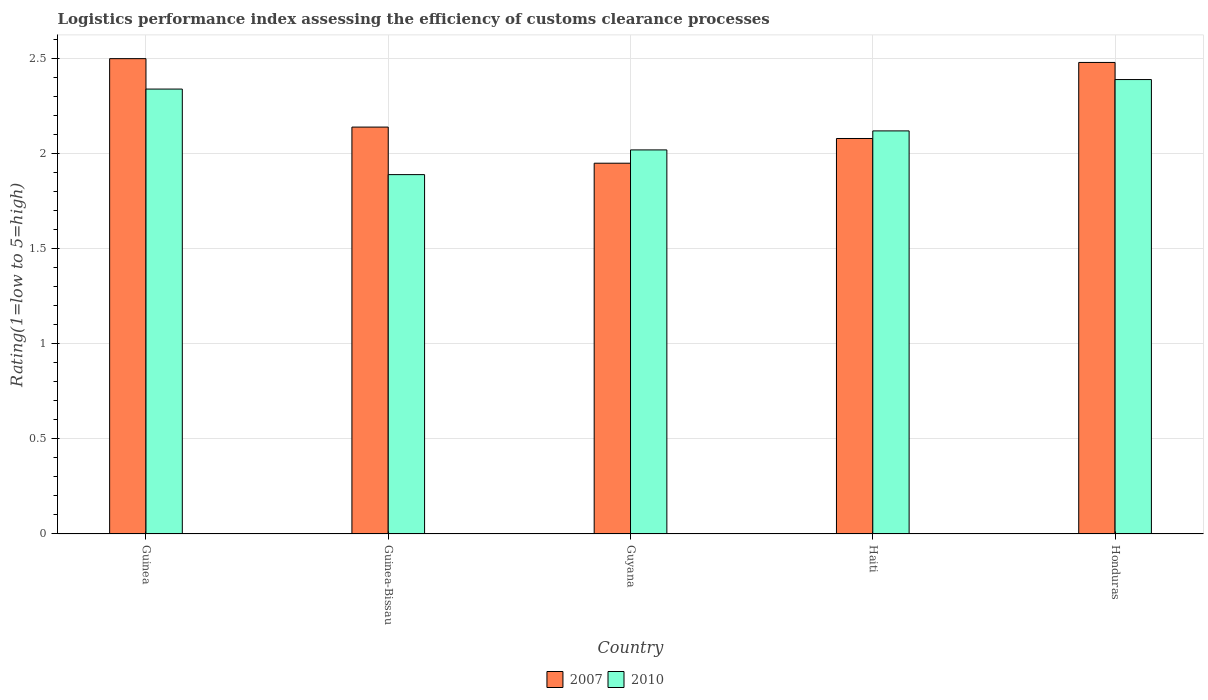How many different coloured bars are there?
Your response must be concise. 2. How many groups of bars are there?
Offer a terse response. 5. Are the number of bars per tick equal to the number of legend labels?
Give a very brief answer. Yes. Are the number of bars on each tick of the X-axis equal?
Offer a terse response. Yes. How many bars are there on the 2nd tick from the left?
Your response must be concise. 2. What is the label of the 3rd group of bars from the left?
Offer a very short reply. Guyana. In how many cases, is the number of bars for a given country not equal to the number of legend labels?
Provide a short and direct response. 0. What is the Logistic performance index in 2010 in Honduras?
Your answer should be very brief. 2.39. Across all countries, what is the maximum Logistic performance index in 2010?
Your answer should be compact. 2.39. Across all countries, what is the minimum Logistic performance index in 2007?
Give a very brief answer. 1.95. In which country was the Logistic performance index in 2007 maximum?
Make the answer very short. Guinea. In which country was the Logistic performance index in 2010 minimum?
Make the answer very short. Guinea-Bissau. What is the total Logistic performance index in 2007 in the graph?
Provide a succinct answer. 11.15. What is the difference between the Logistic performance index in 2007 in Guyana and that in Honduras?
Your answer should be compact. -0.53. What is the difference between the Logistic performance index in 2007 in Guinea-Bissau and the Logistic performance index in 2010 in Guyana?
Your response must be concise. 0.12. What is the average Logistic performance index in 2010 per country?
Your response must be concise. 2.15. What is the difference between the Logistic performance index of/in 2007 and Logistic performance index of/in 2010 in Haiti?
Offer a very short reply. -0.04. What is the ratio of the Logistic performance index in 2007 in Guinea to that in Honduras?
Your answer should be compact. 1.01. What is the difference between the highest and the second highest Logistic performance index in 2010?
Give a very brief answer. 0.05. What is the difference between the highest and the lowest Logistic performance index in 2007?
Provide a short and direct response. 0.55. Is the sum of the Logistic performance index in 2007 in Guinea and Guinea-Bissau greater than the maximum Logistic performance index in 2010 across all countries?
Offer a terse response. Yes. Where does the legend appear in the graph?
Your answer should be very brief. Bottom center. How many legend labels are there?
Provide a succinct answer. 2. How are the legend labels stacked?
Keep it short and to the point. Horizontal. What is the title of the graph?
Give a very brief answer. Logistics performance index assessing the efficiency of customs clearance processes. What is the label or title of the X-axis?
Provide a short and direct response. Country. What is the label or title of the Y-axis?
Your answer should be very brief. Rating(1=low to 5=high). What is the Rating(1=low to 5=high) of 2007 in Guinea?
Offer a terse response. 2.5. What is the Rating(1=low to 5=high) in 2010 in Guinea?
Offer a terse response. 2.34. What is the Rating(1=low to 5=high) in 2007 in Guinea-Bissau?
Make the answer very short. 2.14. What is the Rating(1=low to 5=high) of 2010 in Guinea-Bissau?
Provide a succinct answer. 1.89. What is the Rating(1=low to 5=high) of 2007 in Guyana?
Ensure brevity in your answer.  1.95. What is the Rating(1=low to 5=high) of 2010 in Guyana?
Provide a short and direct response. 2.02. What is the Rating(1=low to 5=high) in 2007 in Haiti?
Provide a short and direct response. 2.08. What is the Rating(1=low to 5=high) in 2010 in Haiti?
Make the answer very short. 2.12. What is the Rating(1=low to 5=high) in 2007 in Honduras?
Your answer should be compact. 2.48. What is the Rating(1=low to 5=high) of 2010 in Honduras?
Give a very brief answer. 2.39. Across all countries, what is the maximum Rating(1=low to 5=high) of 2007?
Your response must be concise. 2.5. Across all countries, what is the maximum Rating(1=low to 5=high) in 2010?
Make the answer very short. 2.39. Across all countries, what is the minimum Rating(1=low to 5=high) of 2007?
Provide a succinct answer. 1.95. Across all countries, what is the minimum Rating(1=low to 5=high) in 2010?
Provide a succinct answer. 1.89. What is the total Rating(1=low to 5=high) of 2007 in the graph?
Ensure brevity in your answer.  11.15. What is the total Rating(1=low to 5=high) of 2010 in the graph?
Make the answer very short. 10.76. What is the difference between the Rating(1=low to 5=high) of 2007 in Guinea and that in Guinea-Bissau?
Your answer should be compact. 0.36. What is the difference between the Rating(1=low to 5=high) in 2010 in Guinea and that in Guinea-Bissau?
Your answer should be very brief. 0.45. What is the difference between the Rating(1=low to 5=high) in 2007 in Guinea and that in Guyana?
Offer a very short reply. 0.55. What is the difference between the Rating(1=low to 5=high) in 2010 in Guinea and that in Guyana?
Your response must be concise. 0.32. What is the difference between the Rating(1=low to 5=high) in 2007 in Guinea and that in Haiti?
Provide a short and direct response. 0.42. What is the difference between the Rating(1=low to 5=high) in 2010 in Guinea and that in Haiti?
Make the answer very short. 0.22. What is the difference between the Rating(1=low to 5=high) in 2007 in Guinea-Bissau and that in Guyana?
Provide a succinct answer. 0.19. What is the difference between the Rating(1=low to 5=high) in 2010 in Guinea-Bissau and that in Guyana?
Offer a terse response. -0.13. What is the difference between the Rating(1=low to 5=high) of 2010 in Guinea-Bissau and that in Haiti?
Your response must be concise. -0.23. What is the difference between the Rating(1=low to 5=high) of 2007 in Guinea-Bissau and that in Honduras?
Ensure brevity in your answer.  -0.34. What is the difference between the Rating(1=low to 5=high) in 2007 in Guyana and that in Haiti?
Provide a short and direct response. -0.13. What is the difference between the Rating(1=low to 5=high) in 2007 in Guyana and that in Honduras?
Your response must be concise. -0.53. What is the difference between the Rating(1=low to 5=high) in 2010 in Guyana and that in Honduras?
Give a very brief answer. -0.37. What is the difference between the Rating(1=low to 5=high) of 2010 in Haiti and that in Honduras?
Keep it short and to the point. -0.27. What is the difference between the Rating(1=low to 5=high) of 2007 in Guinea and the Rating(1=low to 5=high) of 2010 in Guinea-Bissau?
Make the answer very short. 0.61. What is the difference between the Rating(1=low to 5=high) in 2007 in Guinea and the Rating(1=low to 5=high) in 2010 in Guyana?
Make the answer very short. 0.48. What is the difference between the Rating(1=low to 5=high) of 2007 in Guinea and the Rating(1=low to 5=high) of 2010 in Haiti?
Your answer should be compact. 0.38. What is the difference between the Rating(1=low to 5=high) of 2007 in Guinea and the Rating(1=low to 5=high) of 2010 in Honduras?
Make the answer very short. 0.11. What is the difference between the Rating(1=low to 5=high) in 2007 in Guinea-Bissau and the Rating(1=low to 5=high) in 2010 in Guyana?
Offer a terse response. 0.12. What is the difference between the Rating(1=low to 5=high) in 2007 in Guinea-Bissau and the Rating(1=low to 5=high) in 2010 in Honduras?
Provide a short and direct response. -0.25. What is the difference between the Rating(1=low to 5=high) of 2007 in Guyana and the Rating(1=low to 5=high) of 2010 in Haiti?
Your response must be concise. -0.17. What is the difference between the Rating(1=low to 5=high) of 2007 in Guyana and the Rating(1=low to 5=high) of 2010 in Honduras?
Give a very brief answer. -0.44. What is the difference between the Rating(1=low to 5=high) of 2007 in Haiti and the Rating(1=low to 5=high) of 2010 in Honduras?
Keep it short and to the point. -0.31. What is the average Rating(1=low to 5=high) of 2007 per country?
Your answer should be compact. 2.23. What is the average Rating(1=low to 5=high) of 2010 per country?
Offer a terse response. 2.15. What is the difference between the Rating(1=low to 5=high) of 2007 and Rating(1=low to 5=high) of 2010 in Guinea?
Keep it short and to the point. 0.16. What is the difference between the Rating(1=low to 5=high) in 2007 and Rating(1=low to 5=high) in 2010 in Guyana?
Make the answer very short. -0.07. What is the difference between the Rating(1=low to 5=high) of 2007 and Rating(1=low to 5=high) of 2010 in Haiti?
Your answer should be compact. -0.04. What is the difference between the Rating(1=low to 5=high) of 2007 and Rating(1=low to 5=high) of 2010 in Honduras?
Your response must be concise. 0.09. What is the ratio of the Rating(1=low to 5=high) in 2007 in Guinea to that in Guinea-Bissau?
Give a very brief answer. 1.17. What is the ratio of the Rating(1=low to 5=high) of 2010 in Guinea to that in Guinea-Bissau?
Offer a terse response. 1.24. What is the ratio of the Rating(1=low to 5=high) of 2007 in Guinea to that in Guyana?
Offer a terse response. 1.28. What is the ratio of the Rating(1=low to 5=high) of 2010 in Guinea to that in Guyana?
Provide a succinct answer. 1.16. What is the ratio of the Rating(1=low to 5=high) of 2007 in Guinea to that in Haiti?
Your response must be concise. 1.2. What is the ratio of the Rating(1=low to 5=high) of 2010 in Guinea to that in Haiti?
Your answer should be very brief. 1.1. What is the ratio of the Rating(1=low to 5=high) in 2007 in Guinea to that in Honduras?
Make the answer very short. 1.01. What is the ratio of the Rating(1=low to 5=high) of 2010 in Guinea to that in Honduras?
Make the answer very short. 0.98. What is the ratio of the Rating(1=low to 5=high) of 2007 in Guinea-Bissau to that in Guyana?
Your answer should be very brief. 1.1. What is the ratio of the Rating(1=low to 5=high) of 2010 in Guinea-Bissau to that in Guyana?
Keep it short and to the point. 0.94. What is the ratio of the Rating(1=low to 5=high) of 2007 in Guinea-Bissau to that in Haiti?
Ensure brevity in your answer.  1.03. What is the ratio of the Rating(1=low to 5=high) in 2010 in Guinea-Bissau to that in Haiti?
Your answer should be compact. 0.89. What is the ratio of the Rating(1=low to 5=high) of 2007 in Guinea-Bissau to that in Honduras?
Make the answer very short. 0.86. What is the ratio of the Rating(1=low to 5=high) in 2010 in Guinea-Bissau to that in Honduras?
Your answer should be compact. 0.79. What is the ratio of the Rating(1=low to 5=high) in 2010 in Guyana to that in Haiti?
Keep it short and to the point. 0.95. What is the ratio of the Rating(1=low to 5=high) of 2007 in Guyana to that in Honduras?
Provide a short and direct response. 0.79. What is the ratio of the Rating(1=low to 5=high) of 2010 in Guyana to that in Honduras?
Provide a short and direct response. 0.85. What is the ratio of the Rating(1=low to 5=high) of 2007 in Haiti to that in Honduras?
Ensure brevity in your answer.  0.84. What is the ratio of the Rating(1=low to 5=high) in 2010 in Haiti to that in Honduras?
Give a very brief answer. 0.89. What is the difference between the highest and the second highest Rating(1=low to 5=high) in 2007?
Offer a terse response. 0.02. What is the difference between the highest and the lowest Rating(1=low to 5=high) of 2007?
Offer a very short reply. 0.55. 